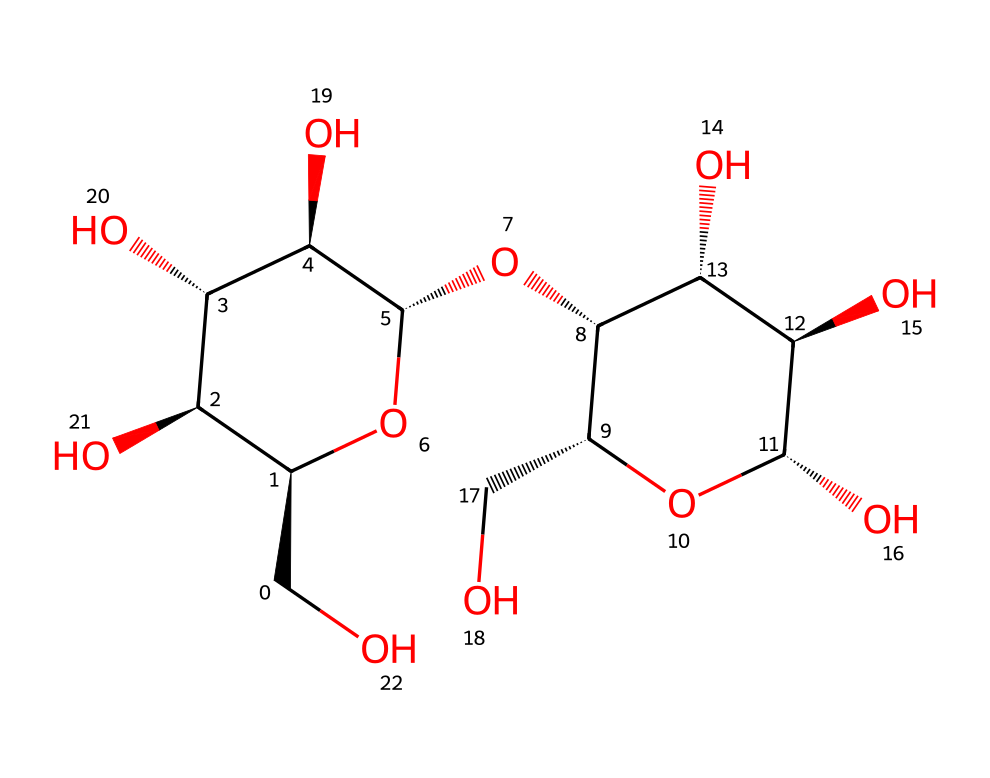What is the total number of carbon atoms in this structure? To find the total number of carbon atoms, we need to count the 'C' symbols in the SMILES representation. Each 'C' represents a carbon atom, and there are a total of 12 'C' symbols.
Answer: 12 What type of glycosidic bonds are present in this molecule? Analyzing the structure, we can recognize that this carbohydrate contains multiple repeating glucose units connected by α(1→4) glycosidic bonds. The connections typically seen in starch are consistent with this notation.
Answer: α(1→4) How many oxygen atoms are in this chemical structure? Similar to counting carbon atoms, we count the 'O' symbols in the SMILES representation. After counting, there are 6 'O' symbols present.
Answer: 6 What is the degree of branching in this starch molecule? In analyzing this structure, starch is known to be mostly linear with some branching. By observing the connections in the SMILES, there is a single branch point indicating low branching typical for amylose.
Answer: low What is the primary function of this carbohydrate in military rations like hardtack? The primary function of starch in hardtack is to serve as a source of energy and calories during long military campaigns, providing necessary sustenance with long shelf life due to its stability.
Answer: energy source Which particular characteristic of starch contributes to its digestibility? The presence of multiple α(1→4) glycosidic bonds in the structure allows enzymes such as amylase to effectively break down the starch into glucose, which is easily absorbed.
Answer: α(1→4) bonds What structural feature indicates that this is a polysaccharide? The molecule consists of multiple repeating units of glucose linked together, which is characteristic of polysaccharides. The presence of multiple units is the defining feature of polysaccharides.
Answer: multiple units 